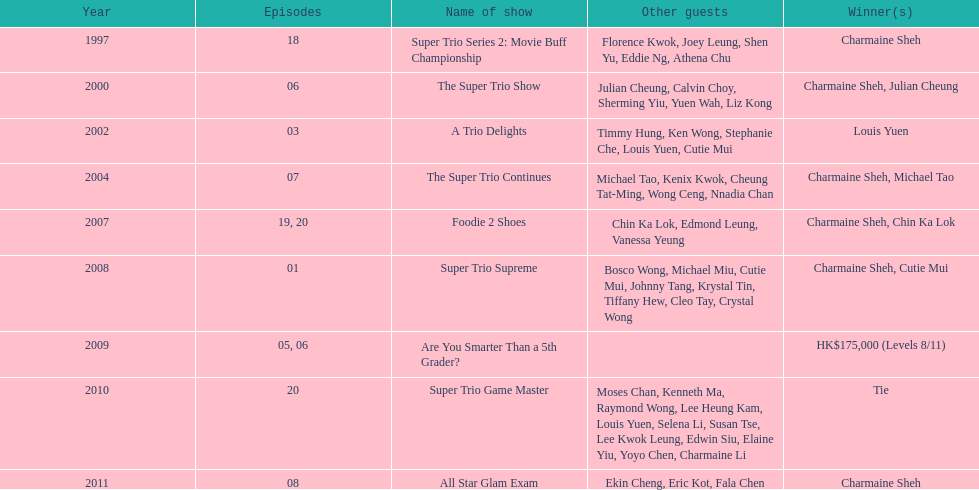What year was the only year were a tie occurred? 2010. 